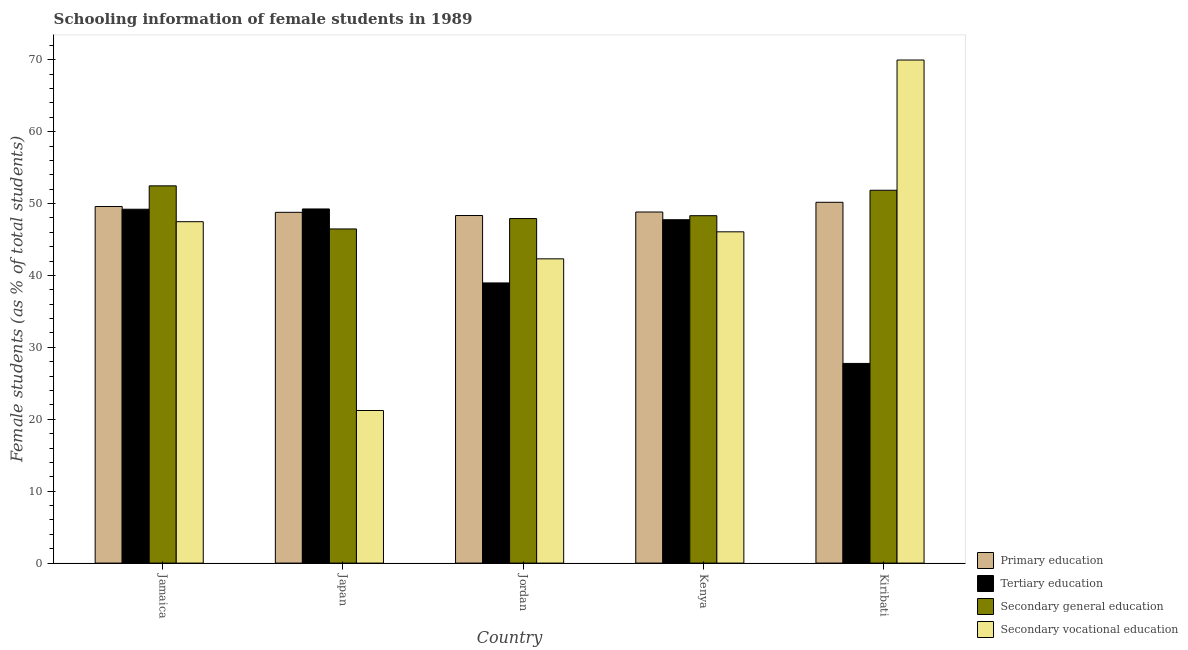How many different coloured bars are there?
Provide a succinct answer. 4. How many groups of bars are there?
Keep it short and to the point. 5. How many bars are there on the 4th tick from the left?
Keep it short and to the point. 4. What is the label of the 5th group of bars from the left?
Your answer should be compact. Kiribati. In how many cases, is the number of bars for a given country not equal to the number of legend labels?
Your response must be concise. 0. What is the percentage of female students in secondary education in Jordan?
Ensure brevity in your answer.  47.92. Across all countries, what is the maximum percentage of female students in secondary education?
Provide a succinct answer. 52.46. Across all countries, what is the minimum percentage of female students in primary education?
Your response must be concise. 48.34. In which country was the percentage of female students in secondary vocational education maximum?
Ensure brevity in your answer.  Kiribati. In which country was the percentage of female students in tertiary education minimum?
Keep it short and to the point. Kiribati. What is the total percentage of female students in secondary vocational education in the graph?
Give a very brief answer. 227.04. What is the difference between the percentage of female students in secondary vocational education in Kenya and that in Kiribati?
Offer a very short reply. -23.89. What is the difference between the percentage of female students in secondary education in Kenya and the percentage of female students in primary education in Jordan?
Offer a very short reply. -0.02. What is the average percentage of female students in tertiary education per country?
Keep it short and to the point. 42.59. What is the difference between the percentage of female students in secondary vocational education and percentage of female students in tertiary education in Kenya?
Keep it short and to the point. -1.68. In how many countries, is the percentage of female students in primary education greater than 4 %?
Provide a short and direct response. 5. What is the ratio of the percentage of female students in secondary education in Jordan to that in Kiribati?
Give a very brief answer. 0.92. Is the difference between the percentage of female students in primary education in Jamaica and Kiribati greater than the difference between the percentage of female students in secondary vocational education in Jamaica and Kiribati?
Offer a very short reply. Yes. What is the difference between the highest and the second highest percentage of female students in secondary education?
Ensure brevity in your answer.  0.61. What is the difference between the highest and the lowest percentage of female students in secondary vocational education?
Make the answer very short. 48.74. Is the sum of the percentage of female students in secondary vocational education in Kenya and Kiribati greater than the maximum percentage of female students in primary education across all countries?
Offer a very short reply. Yes. Is it the case that in every country, the sum of the percentage of female students in secondary vocational education and percentage of female students in primary education is greater than the sum of percentage of female students in tertiary education and percentage of female students in secondary education?
Provide a succinct answer. No. What does the 3rd bar from the left in Jamaica represents?
Offer a very short reply. Secondary general education. Is it the case that in every country, the sum of the percentage of female students in primary education and percentage of female students in tertiary education is greater than the percentage of female students in secondary education?
Your answer should be compact. Yes. Are all the bars in the graph horizontal?
Your answer should be compact. No. How many countries are there in the graph?
Provide a short and direct response. 5. Are the values on the major ticks of Y-axis written in scientific E-notation?
Provide a short and direct response. No. Does the graph contain grids?
Make the answer very short. No. Where does the legend appear in the graph?
Ensure brevity in your answer.  Bottom right. How many legend labels are there?
Give a very brief answer. 4. What is the title of the graph?
Your answer should be very brief. Schooling information of female students in 1989. What is the label or title of the X-axis?
Offer a terse response. Country. What is the label or title of the Y-axis?
Ensure brevity in your answer.  Female students (as % of total students). What is the Female students (as % of total students) of Primary education in Jamaica?
Give a very brief answer. 49.59. What is the Female students (as % of total students) of Tertiary education in Jamaica?
Offer a very short reply. 49.21. What is the Female students (as % of total students) of Secondary general education in Jamaica?
Provide a succinct answer. 52.46. What is the Female students (as % of total students) in Secondary vocational education in Jamaica?
Give a very brief answer. 47.48. What is the Female students (as % of total students) of Primary education in Japan?
Ensure brevity in your answer.  48.78. What is the Female students (as % of total students) in Tertiary education in Japan?
Provide a short and direct response. 49.25. What is the Female students (as % of total students) in Secondary general education in Japan?
Provide a succinct answer. 46.47. What is the Female students (as % of total students) in Secondary vocational education in Japan?
Offer a very short reply. 21.22. What is the Female students (as % of total students) in Primary education in Jordan?
Offer a terse response. 48.34. What is the Female students (as % of total students) in Tertiary education in Jordan?
Your answer should be compact. 38.96. What is the Female students (as % of total students) of Secondary general education in Jordan?
Provide a short and direct response. 47.92. What is the Female students (as % of total students) of Secondary vocational education in Jordan?
Offer a very short reply. 42.31. What is the Female students (as % of total students) in Primary education in Kenya?
Ensure brevity in your answer.  48.82. What is the Female students (as % of total students) of Tertiary education in Kenya?
Offer a terse response. 47.75. What is the Female students (as % of total students) in Secondary general education in Kenya?
Your response must be concise. 48.31. What is the Female students (as % of total students) in Secondary vocational education in Kenya?
Keep it short and to the point. 46.07. What is the Female students (as % of total students) of Primary education in Kiribati?
Ensure brevity in your answer.  50.18. What is the Female students (as % of total students) in Tertiary education in Kiribati?
Your response must be concise. 27.77. What is the Female students (as % of total students) in Secondary general education in Kiribati?
Provide a succinct answer. 51.85. What is the Female students (as % of total students) of Secondary vocational education in Kiribati?
Make the answer very short. 69.96. Across all countries, what is the maximum Female students (as % of total students) in Primary education?
Provide a succinct answer. 50.18. Across all countries, what is the maximum Female students (as % of total students) in Tertiary education?
Give a very brief answer. 49.25. Across all countries, what is the maximum Female students (as % of total students) of Secondary general education?
Keep it short and to the point. 52.46. Across all countries, what is the maximum Female students (as % of total students) of Secondary vocational education?
Your answer should be compact. 69.96. Across all countries, what is the minimum Female students (as % of total students) of Primary education?
Offer a terse response. 48.34. Across all countries, what is the minimum Female students (as % of total students) in Tertiary education?
Provide a short and direct response. 27.77. Across all countries, what is the minimum Female students (as % of total students) of Secondary general education?
Your answer should be compact. 46.47. Across all countries, what is the minimum Female students (as % of total students) of Secondary vocational education?
Provide a succinct answer. 21.22. What is the total Female students (as % of total students) in Primary education in the graph?
Give a very brief answer. 245.71. What is the total Female students (as % of total students) of Tertiary education in the graph?
Provide a succinct answer. 212.94. What is the total Female students (as % of total students) of Secondary general education in the graph?
Provide a short and direct response. 247.01. What is the total Female students (as % of total students) of Secondary vocational education in the graph?
Offer a terse response. 227.04. What is the difference between the Female students (as % of total students) of Primary education in Jamaica and that in Japan?
Provide a short and direct response. 0.81. What is the difference between the Female students (as % of total students) of Tertiary education in Jamaica and that in Japan?
Ensure brevity in your answer.  -0.04. What is the difference between the Female students (as % of total students) in Secondary general education in Jamaica and that in Japan?
Your response must be concise. 5.99. What is the difference between the Female students (as % of total students) in Secondary vocational education in Jamaica and that in Japan?
Ensure brevity in your answer.  26.26. What is the difference between the Female students (as % of total students) in Primary education in Jamaica and that in Jordan?
Offer a very short reply. 1.25. What is the difference between the Female students (as % of total students) of Tertiary education in Jamaica and that in Jordan?
Your response must be concise. 10.25. What is the difference between the Female students (as % of total students) in Secondary general education in Jamaica and that in Jordan?
Offer a terse response. 4.55. What is the difference between the Female students (as % of total students) of Secondary vocational education in Jamaica and that in Jordan?
Make the answer very short. 5.17. What is the difference between the Female students (as % of total students) in Primary education in Jamaica and that in Kenya?
Make the answer very short. 0.76. What is the difference between the Female students (as % of total students) of Tertiary education in Jamaica and that in Kenya?
Keep it short and to the point. 1.46. What is the difference between the Female students (as % of total students) in Secondary general education in Jamaica and that in Kenya?
Offer a very short reply. 4.15. What is the difference between the Female students (as % of total students) in Secondary vocational education in Jamaica and that in Kenya?
Offer a terse response. 1.41. What is the difference between the Female students (as % of total students) of Primary education in Jamaica and that in Kiribati?
Your answer should be compact. -0.59. What is the difference between the Female students (as % of total students) of Tertiary education in Jamaica and that in Kiribati?
Provide a short and direct response. 21.45. What is the difference between the Female students (as % of total students) in Secondary general education in Jamaica and that in Kiribati?
Give a very brief answer. 0.61. What is the difference between the Female students (as % of total students) of Secondary vocational education in Jamaica and that in Kiribati?
Give a very brief answer. -22.48. What is the difference between the Female students (as % of total students) of Primary education in Japan and that in Jordan?
Keep it short and to the point. 0.45. What is the difference between the Female students (as % of total students) of Tertiary education in Japan and that in Jordan?
Provide a short and direct response. 10.29. What is the difference between the Female students (as % of total students) of Secondary general education in Japan and that in Jordan?
Your answer should be very brief. -1.45. What is the difference between the Female students (as % of total students) of Secondary vocational education in Japan and that in Jordan?
Ensure brevity in your answer.  -21.09. What is the difference between the Female students (as % of total students) of Primary education in Japan and that in Kenya?
Offer a very short reply. -0.04. What is the difference between the Female students (as % of total students) of Tertiary education in Japan and that in Kenya?
Your response must be concise. 1.5. What is the difference between the Female students (as % of total students) of Secondary general education in Japan and that in Kenya?
Offer a terse response. -1.84. What is the difference between the Female students (as % of total students) of Secondary vocational education in Japan and that in Kenya?
Your answer should be compact. -24.85. What is the difference between the Female students (as % of total students) of Primary education in Japan and that in Kiribati?
Keep it short and to the point. -1.4. What is the difference between the Female students (as % of total students) of Tertiary education in Japan and that in Kiribati?
Offer a terse response. 21.48. What is the difference between the Female students (as % of total students) of Secondary general education in Japan and that in Kiribati?
Your answer should be compact. -5.38. What is the difference between the Female students (as % of total students) in Secondary vocational education in Japan and that in Kiribati?
Provide a succinct answer. -48.74. What is the difference between the Female students (as % of total students) in Primary education in Jordan and that in Kenya?
Make the answer very short. -0.49. What is the difference between the Female students (as % of total students) of Tertiary education in Jordan and that in Kenya?
Offer a terse response. -8.79. What is the difference between the Female students (as % of total students) in Secondary general education in Jordan and that in Kenya?
Give a very brief answer. -0.4. What is the difference between the Female students (as % of total students) in Secondary vocational education in Jordan and that in Kenya?
Ensure brevity in your answer.  -3.76. What is the difference between the Female students (as % of total students) in Primary education in Jordan and that in Kiribati?
Make the answer very short. -1.84. What is the difference between the Female students (as % of total students) of Tertiary education in Jordan and that in Kiribati?
Keep it short and to the point. 11.19. What is the difference between the Female students (as % of total students) of Secondary general education in Jordan and that in Kiribati?
Make the answer very short. -3.94. What is the difference between the Female students (as % of total students) in Secondary vocational education in Jordan and that in Kiribati?
Make the answer very short. -27.65. What is the difference between the Female students (as % of total students) in Primary education in Kenya and that in Kiribati?
Offer a terse response. -1.35. What is the difference between the Female students (as % of total students) of Tertiary education in Kenya and that in Kiribati?
Provide a succinct answer. 19.99. What is the difference between the Female students (as % of total students) in Secondary general education in Kenya and that in Kiribati?
Keep it short and to the point. -3.54. What is the difference between the Female students (as % of total students) in Secondary vocational education in Kenya and that in Kiribati?
Offer a very short reply. -23.89. What is the difference between the Female students (as % of total students) in Primary education in Jamaica and the Female students (as % of total students) in Tertiary education in Japan?
Your response must be concise. 0.34. What is the difference between the Female students (as % of total students) in Primary education in Jamaica and the Female students (as % of total students) in Secondary general education in Japan?
Ensure brevity in your answer.  3.12. What is the difference between the Female students (as % of total students) in Primary education in Jamaica and the Female students (as % of total students) in Secondary vocational education in Japan?
Provide a succinct answer. 28.37. What is the difference between the Female students (as % of total students) of Tertiary education in Jamaica and the Female students (as % of total students) of Secondary general education in Japan?
Your answer should be very brief. 2.74. What is the difference between the Female students (as % of total students) of Tertiary education in Jamaica and the Female students (as % of total students) of Secondary vocational education in Japan?
Your answer should be very brief. 27.99. What is the difference between the Female students (as % of total students) in Secondary general education in Jamaica and the Female students (as % of total students) in Secondary vocational education in Japan?
Ensure brevity in your answer.  31.24. What is the difference between the Female students (as % of total students) in Primary education in Jamaica and the Female students (as % of total students) in Tertiary education in Jordan?
Your answer should be very brief. 10.63. What is the difference between the Female students (as % of total students) in Primary education in Jamaica and the Female students (as % of total students) in Secondary general education in Jordan?
Give a very brief answer. 1.67. What is the difference between the Female students (as % of total students) in Primary education in Jamaica and the Female students (as % of total students) in Secondary vocational education in Jordan?
Provide a short and direct response. 7.28. What is the difference between the Female students (as % of total students) in Tertiary education in Jamaica and the Female students (as % of total students) in Secondary general education in Jordan?
Offer a terse response. 1.3. What is the difference between the Female students (as % of total students) in Tertiary education in Jamaica and the Female students (as % of total students) in Secondary vocational education in Jordan?
Give a very brief answer. 6.9. What is the difference between the Female students (as % of total students) of Secondary general education in Jamaica and the Female students (as % of total students) of Secondary vocational education in Jordan?
Your answer should be very brief. 10.15. What is the difference between the Female students (as % of total students) in Primary education in Jamaica and the Female students (as % of total students) in Tertiary education in Kenya?
Give a very brief answer. 1.84. What is the difference between the Female students (as % of total students) of Primary education in Jamaica and the Female students (as % of total students) of Secondary general education in Kenya?
Your answer should be compact. 1.28. What is the difference between the Female students (as % of total students) of Primary education in Jamaica and the Female students (as % of total students) of Secondary vocational education in Kenya?
Your response must be concise. 3.52. What is the difference between the Female students (as % of total students) of Tertiary education in Jamaica and the Female students (as % of total students) of Secondary general education in Kenya?
Offer a very short reply. 0.9. What is the difference between the Female students (as % of total students) of Tertiary education in Jamaica and the Female students (as % of total students) of Secondary vocational education in Kenya?
Give a very brief answer. 3.14. What is the difference between the Female students (as % of total students) in Secondary general education in Jamaica and the Female students (as % of total students) in Secondary vocational education in Kenya?
Your answer should be very brief. 6.39. What is the difference between the Female students (as % of total students) in Primary education in Jamaica and the Female students (as % of total students) in Tertiary education in Kiribati?
Your response must be concise. 21.82. What is the difference between the Female students (as % of total students) in Primary education in Jamaica and the Female students (as % of total students) in Secondary general education in Kiribati?
Provide a short and direct response. -2.26. What is the difference between the Female students (as % of total students) in Primary education in Jamaica and the Female students (as % of total students) in Secondary vocational education in Kiribati?
Ensure brevity in your answer.  -20.37. What is the difference between the Female students (as % of total students) in Tertiary education in Jamaica and the Female students (as % of total students) in Secondary general education in Kiribati?
Your response must be concise. -2.64. What is the difference between the Female students (as % of total students) in Tertiary education in Jamaica and the Female students (as % of total students) in Secondary vocational education in Kiribati?
Your response must be concise. -20.75. What is the difference between the Female students (as % of total students) of Secondary general education in Jamaica and the Female students (as % of total students) of Secondary vocational education in Kiribati?
Offer a very short reply. -17.5. What is the difference between the Female students (as % of total students) of Primary education in Japan and the Female students (as % of total students) of Tertiary education in Jordan?
Ensure brevity in your answer.  9.82. What is the difference between the Female students (as % of total students) in Primary education in Japan and the Female students (as % of total students) in Secondary general education in Jordan?
Your response must be concise. 0.87. What is the difference between the Female students (as % of total students) in Primary education in Japan and the Female students (as % of total students) in Secondary vocational education in Jordan?
Your answer should be very brief. 6.47. What is the difference between the Female students (as % of total students) of Tertiary education in Japan and the Female students (as % of total students) of Secondary general education in Jordan?
Give a very brief answer. 1.33. What is the difference between the Female students (as % of total students) of Tertiary education in Japan and the Female students (as % of total students) of Secondary vocational education in Jordan?
Give a very brief answer. 6.94. What is the difference between the Female students (as % of total students) in Secondary general education in Japan and the Female students (as % of total students) in Secondary vocational education in Jordan?
Give a very brief answer. 4.16. What is the difference between the Female students (as % of total students) in Primary education in Japan and the Female students (as % of total students) in Tertiary education in Kenya?
Offer a terse response. 1.03. What is the difference between the Female students (as % of total students) of Primary education in Japan and the Female students (as % of total students) of Secondary general education in Kenya?
Make the answer very short. 0.47. What is the difference between the Female students (as % of total students) in Primary education in Japan and the Female students (as % of total students) in Secondary vocational education in Kenya?
Your answer should be very brief. 2.71. What is the difference between the Female students (as % of total students) of Tertiary education in Japan and the Female students (as % of total students) of Secondary general education in Kenya?
Keep it short and to the point. 0.94. What is the difference between the Female students (as % of total students) of Tertiary education in Japan and the Female students (as % of total students) of Secondary vocational education in Kenya?
Keep it short and to the point. 3.18. What is the difference between the Female students (as % of total students) in Secondary general education in Japan and the Female students (as % of total students) in Secondary vocational education in Kenya?
Make the answer very short. 0.4. What is the difference between the Female students (as % of total students) in Primary education in Japan and the Female students (as % of total students) in Tertiary education in Kiribati?
Your answer should be very brief. 21.02. What is the difference between the Female students (as % of total students) of Primary education in Japan and the Female students (as % of total students) of Secondary general education in Kiribati?
Offer a terse response. -3.07. What is the difference between the Female students (as % of total students) in Primary education in Japan and the Female students (as % of total students) in Secondary vocational education in Kiribati?
Offer a very short reply. -21.18. What is the difference between the Female students (as % of total students) of Tertiary education in Japan and the Female students (as % of total students) of Secondary general education in Kiribati?
Give a very brief answer. -2.6. What is the difference between the Female students (as % of total students) of Tertiary education in Japan and the Female students (as % of total students) of Secondary vocational education in Kiribati?
Provide a short and direct response. -20.71. What is the difference between the Female students (as % of total students) in Secondary general education in Japan and the Female students (as % of total students) in Secondary vocational education in Kiribati?
Your answer should be compact. -23.49. What is the difference between the Female students (as % of total students) in Primary education in Jordan and the Female students (as % of total students) in Tertiary education in Kenya?
Your response must be concise. 0.58. What is the difference between the Female students (as % of total students) of Primary education in Jordan and the Female students (as % of total students) of Secondary general education in Kenya?
Keep it short and to the point. 0.02. What is the difference between the Female students (as % of total students) in Primary education in Jordan and the Female students (as % of total students) in Secondary vocational education in Kenya?
Your response must be concise. 2.27. What is the difference between the Female students (as % of total students) of Tertiary education in Jordan and the Female students (as % of total students) of Secondary general education in Kenya?
Keep it short and to the point. -9.35. What is the difference between the Female students (as % of total students) of Tertiary education in Jordan and the Female students (as % of total students) of Secondary vocational education in Kenya?
Keep it short and to the point. -7.11. What is the difference between the Female students (as % of total students) in Secondary general education in Jordan and the Female students (as % of total students) in Secondary vocational education in Kenya?
Provide a succinct answer. 1.85. What is the difference between the Female students (as % of total students) in Primary education in Jordan and the Female students (as % of total students) in Tertiary education in Kiribati?
Provide a short and direct response. 20.57. What is the difference between the Female students (as % of total students) of Primary education in Jordan and the Female students (as % of total students) of Secondary general education in Kiribati?
Offer a very short reply. -3.51. What is the difference between the Female students (as % of total students) of Primary education in Jordan and the Female students (as % of total students) of Secondary vocational education in Kiribati?
Provide a succinct answer. -21.62. What is the difference between the Female students (as % of total students) in Tertiary education in Jordan and the Female students (as % of total students) in Secondary general education in Kiribati?
Your response must be concise. -12.89. What is the difference between the Female students (as % of total students) in Tertiary education in Jordan and the Female students (as % of total students) in Secondary vocational education in Kiribati?
Ensure brevity in your answer.  -31. What is the difference between the Female students (as % of total students) in Secondary general education in Jordan and the Female students (as % of total students) in Secondary vocational education in Kiribati?
Your response must be concise. -22.05. What is the difference between the Female students (as % of total students) in Primary education in Kenya and the Female students (as % of total students) in Tertiary education in Kiribati?
Make the answer very short. 21.06. What is the difference between the Female students (as % of total students) in Primary education in Kenya and the Female students (as % of total students) in Secondary general education in Kiribati?
Offer a terse response. -3.03. What is the difference between the Female students (as % of total students) in Primary education in Kenya and the Female students (as % of total students) in Secondary vocational education in Kiribati?
Provide a short and direct response. -21.14. What is the difference between the Female students (as % of total students) in Tertiary education in Kenya and the Female students (as % of total students) in Secondary general education in Kiribati?
Ensure brevity in your answer.  -4.1. What is the difference between the Female students (as % of total students) in Tertiary education in Kenya and the Female students (as % of total students) in Secondary vocational education in Kiribati?
Offer a very short reply. -22.21. What is the difference between the Female students (as % of total students) of Secondary general education in Kenya and the Female students (as % of total students) of Secondary vocational education in Kiribati?
Your answer should be very brief. -21.65. What is the average Female students (as % of total students) of Primary education per country?
Provide a short and direct response. 49.14. What is the average Female students (as % of total students) of Tertiary education per country?
Provide a succinct answer. 42.59. What is the average Female students (as % of total students) of Secondary general education per country?
Your answer should be very brief. 49.4. What is the average Female students (as % of total students) of Secondary vocational education per country?
Your response must be concise. 45.41. What is the difference between the Female students (as % of total students) in Primary education and Female students (as % of total students) in Tertiary education in Jamaica?
Offer a terse response. 0.38. What is the difference between the Female students (as % of total students) of Primary education and Female students (as % of total students) of Secondary general education in Jamaica?
Provide a short and direct response. -2.87. What is the difference between the Female students (as % of total students) of Primary education and Female students (as % of total students) of Secondary vocational education in Jamaica?
Make the answer very short. 2.11. What is the difference between the Female students (as % of total students) of Tertiary education and Female students (as % of total students) of Secondary general education in Jamaica?
Provide a short and direct response. -3.25. What is the difference between the Female students (as % of total students) in Tertiary education and Female students (as % of total students) in Secondary vocational education in Jamaica?
Your answer should be compact. 1.73. What is the difference between the Female students (as % of total students) in Secondary general education and Female students (as % of total students) in Secondary vocational education in Jamaica?
Provide a short and direct response. 4.99. What is the difference between the Female students (as % of total students) of Primary education and Female students (as % of total students) of Tertiary education in Japan?
Provide a succinct answer. -0.47. What is the difference between the Female students (as % of total students) in Primary education and Female students (as % of total students) in Secondary general education in Japan?
Give a very brief answer. 2.31. What is the difference between the Female students (as % of total students) of Primary education and Female students (as % of total students) of Secondary vocational education in Japan?
Give a very brief answer. 27.56. What is the difference between the Female students (as % of total students) of Tertiary education and Female students (as % of total students) of Secondary general education in Japan?
Provide a succinct answer. 2.78. What is the difference between the Female students (as % of total students) in Tertiary education and Female students (as % of total students) in Secondary vocational education in Japan?
Your answer should be compact. 28.03. What is the difference between the Female students (as % of total students) in Secondary general education and Female students (as % of total students) in Secondary vocational education in Japan?
Provide a succinct answer. 25.25. What is the difference between the Female students (as % of total students) in Primary education and Female students (as % of total students) in Tertiary education in Jordan?
Keep it short and to the point. 9.37. What is the difference between the Female students (as % of total students) of Primary education and Female students (as % of total students) of Secondary general education in Jordan?
Your response must be concise. 0.42. What is the difference between the Female students (as % of total students) in Primary education and Female students (as % of total students) in Secondary vocational education in Jordan?
Give a very brief answer. 6.02. What is the difference between the Female students (as % of total students) in Tertiary education and Female students (as % of total students) in Secondary general education in Jordan?
Provide a succinct answer. -8.95. What is the difference between the Female students (as % of total students) in Tertiary education and Female students (as % of total students) in Secondary vocational education in Jordan?
Provide a succinct answer. -3.35. What is the difference between the Female students (as % of total students) in Secondary general education and Female students (as % of total students) in Secondary vocational education in Jordan?
Your answer should be very brief. 5.6. What is the difference between the Female students (as % of total students) in Primary education and Female students (as % of total students) in Tertiary education in Kenya?
Make the answer very short. 1.07. What is the difference between the Female students (as % of total students) of Primary education and Female students (as % of total students) of Secondary general education in Kenya?
Ensure brevity in your answer.  0.51. What is the difference between the Female students (as % of total students) in Primary education and Female students (as % of total students) in Secondary vocational education in Kenya?
Offer a terse response. 2.75. What is the difference between the Female students (as % of total students) of Tertiary education and Female students (as % of total students) of Secondary general education in Kenya?
Give a very brief answer. -0.56. What is the difference between the Female students (as % of total students) of Tertiary education and Female students (as % of total students) of Secondary vocational education in Kenya?
Provide a short and direct response. 1.68. What is the difference between the Female students (as % of total students) of Secondary general education and Female students (as % of total students) of Secondary vocational education in Kenya?
Offer a very short reply. 2.24. What is the difference between the Female students (as % of total students) in Primary education and Female students (as % of total students) in Tertiary education in Kiribati?
Your response must be concise. 22.41. What is the difference between the Female students (as % of total students) in Primary education and Female students (as % of total students) in Secondary general education in Kiribati?
Keep it short and to the point. -1.67. What is the difference between the Female students (as % of total students) in Primary education and Female students (as % of total students) in Secondary vocational education in Kiribati?
Provide a short and direct response. -19.78. What is the difference between the Female students (as % of total students) of Tertiary education and Female students (as % of total students) of Secondary general education in Kiribati?
Keep it short and to the point. -24.08. What is the difference between the Female students (as % of total students) of Tertiary education and Female students (as % of total students) of Secondary vocational education in Kiribati?
Your answer should be compact. -42.19. What is the difference between the Female students (as % of total students) of Secondary general education and Female students (as % of total students) of Secondary vocational education in Kiribati?
Keep it short and to the point. -18.11. What is the ratio of the Female students (as % of total students) in Primary education in Jamaica to that in Japan?
Ensure brevity in your answer.  1.02. What is the ratio of the Female students (as % of total students) of Tertiary education in Jamaica to that in Japan?
Make the answer very short. 1. What is the ratio of the Female students (as % of total students) of Secondary general education in Jamaica to that in Japan?
Offer a terse response. 1.13. What is the ratio of the Female students (as % of total students) of Secondary vocational education in Jamaica to that in Japan?
Your answer should be very brief. 2.24. What is the ratio of the Female students (as % of total students) of Primary education in Jamaica to that in Jordan?
Keep it short and to the point. 1.03. What is the ratio of the Female students (as % of total students) in Tertiary education in Jamaica to that in Jordan?
Ensure brevity in your answer.  1.26. What is the ratio of the Female students (as % of total students) of Secondary general education in Jamaica to that in Jordan?
Keep it short and to the point. 1.09. What is the ratio of the Female students (as % of total students) of Secondary vocational education in Jamaica to that in Jordan?
Your answer should be very brief. 1.12. What is the ratio of the Female students (as % of total students) in Primary education in Jamaica to that in Kenya?
Your answer should be compact. 1.02. What is the ratio of the Female students (as % of total students) of Tertiary education in Jamaica to that in Kenya?
Provide a succinct answer. 1.03. What is the ratio of the Female students (as % of total students) of Secondary general education in Jamaica to that in Kenya?
Give a very brief answer. 1.09. What is the ratio of the Female students (as % of total students) in Secondary vocational education in Jamaica to that in Kenya?
Offer a very short reply. 1.03. What is the ratio of the Female students (as % of total students) in Primary education in Jamaica to that in Kiribati?
Your response must be concise. 0.99. What is the ratio of the Female students (as % of total students) of Tertiary education in Jamaica to that in Kiribati?
Offer a terse response. 1.77. What is the ratio of the Female students (as % of total students) of Secondary general education in Jamaica to that in Kiribati?
Offer a very short reply. 1.01. What is the ratio of the Female students (as % of total students) in Secondary vocational education in Jamaica to that in Kiribati?
Provide a succinct answer. 0.68. What is the ratio of the Female students (as % of total students) in Primary education in Japan to that in Jordan?
Offer a terse response. 1.01. What is the ratio of the Female students (as % of total students) of Tertiary education in Japan to that in Jordan?
Offer a very short reply. 1.26. What is the ratio of the Female students (as % of total students) of Secondary general education in Japan to that in Jordan?
Keep it short and to the point. 0.97. What is the ratio of the Female students (as % of total students) of Secondary vocational education in Japan to that in Jordan?
Provide a short and direct response. 0.5. What is the ratio of the Female students (as % of total students) in Primary education in Japan to that in Kenya?
Provide a short and direct response. 1. What is the ratio of the Female students (as % of total students) in Tertiary education in Japan to that in Kenya?
Keep it short and to the point. 1.03. What is the ratio of the Female students (as % of total students) in Secondary general education in Japan to that in Kenya?
Make the answer very short. 0.96. What is the ratio of the Female students (as % of total students) of Secondary vocational education in Japan to that in Kenya?
Offer a terse response. 0.46. What is the ratio of the Female students (as % of total students) of Primary education in Japan to that in Kiribati?
Offer a terse response. 0.97. What is the ratio of the Female students (as % of total students) in Tertiary education in Japan to that in Kiribati?
Your answer should be very brief. 1.77. What is the ratio of the Female students (as % of total students) in Secondary general education in Japan to that in Kiribati?
Keep it short and to the point. 0.9. What is the ratio of the Female students (as % of total students) of Secondary vocational education in Japan to that in Kiribati?
Your response must be concise. 0.3. What is the ratio of the Female students (as % of total students) of Tertiary education in Jordan to that in Kenya?
Provide a succinct answer. 0.82. What is the ratio of the Female students (as % of total students) in Secondary general education in Jordan to that in Kenya?
Provide a short and direct response. 0.99. What is the ratio of the Female students (as % of total students) in Secondary vocational education in Jordan to that in Kenya?
Offer a very short reply. 0.92. What is the ratio of the Female students (as % of total students) of Primary education in Jordan to that in Kiribati?
Give a very brief answer. 0.96. What is the ratio of the Female students (as % of total students) of Tertiary education in Jordan to that in Kiribati?
Provide a succinct answer. 1.4. What is the ratio of the Female students (as % of total students) in Secondary general education in Jordan to that in Kiribati?
Offer a terse response. 0.92. What is the ratio of the Female students (as % of total students) of Secondary vocational education in Jordan to that in Kiribati?
Provide a succinct answer. 0.6. What is the ratio of the Female students (as % of total students) of Tertiary education in Kenya to that in Kiribati?
Provide a short and direct response. 1.72. What is the ratio of the Female students (as % of total students) of Secondary general education in Kenya to that in Kiribati?
Your answer should be compact. 0.93. What is the ratio of the Female students (as % of total students) of Secondary vocational education in Kenya to that in Kiribati?
Ensure brevity in your answer.  0.66. What is the difference between the highest and the second highest Female students (as % of total students) of Primary education?
Offer a terse response. 0.59. What is the difference between the highest and the second highest Female students (as % of total students) in Tertiary education?
Provide a short and direct response. 0.04. What is the difference between the highest and the second highest Female students (as % of total students) of Secondary general education?
Offer a terse response. 0.61. What is the difference between the highest and the second highest Female students (as % of total students) of Secondary vocational education?
Give a very brief answer. 22.48. What is the difference between the highest and the lowest Female students (as % of total students) in Primary education?
Provide a succinct answer. 1.84. What is the difference between the highest and the lowest Female students (as % of total students) of Tertiary education?
Provide a short and direct response. 21.48. What is the difference between the highest and the lowest Female students (as % of total students) of Secondary general education?
Provide a short and direct response. 5.99. What is the difference between the highest and the lowest Female students (as % of total students) of Secondary vocational education?
Offer a very short reply. 48.74. 